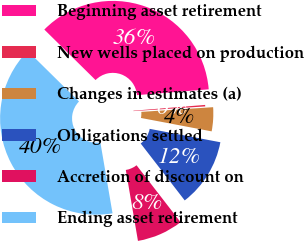Convert chart to OTSL. <chart><loc_0><loc_0><loc_500><loc_500><pie_chart><fcel>Beginning asset retirement<fcel>New wells placed on production<fcel>Changes in estimates (a)<fcel>Obligations settled<fcel>Accretion of discount on<fcel>Ending asset retirement<nl><fcel>36.33%<fcel>0.25%<fcel>4.02%<fcel>11.54%<fcel>7.78%<fcel>40.09%<nl></chart> 